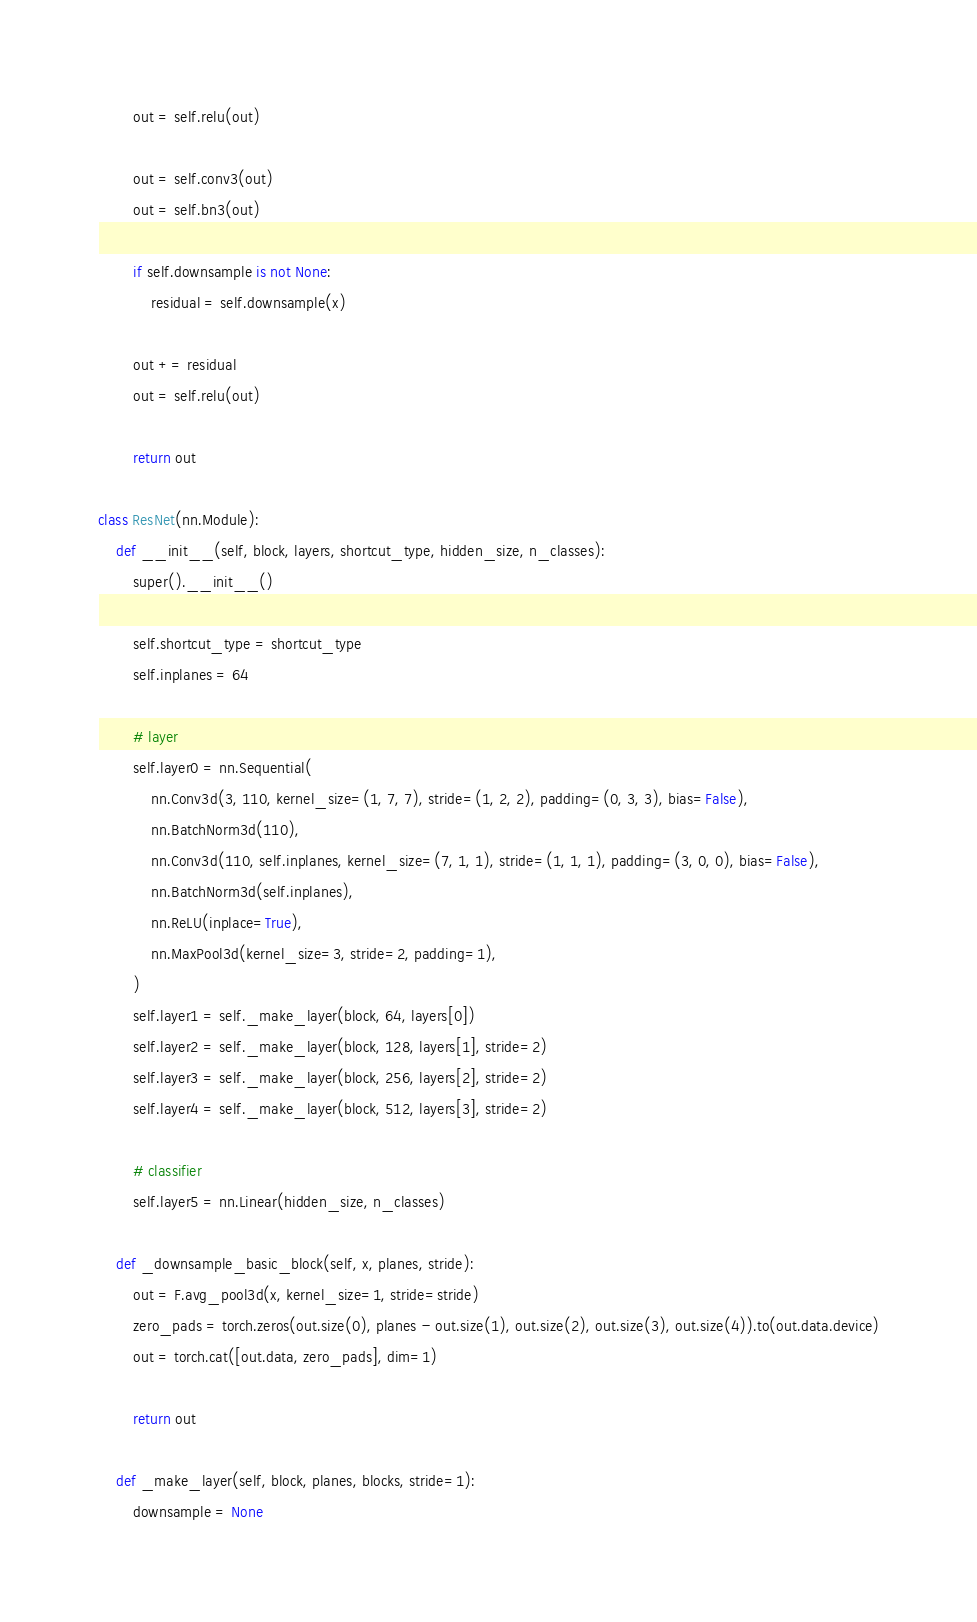<code> <loc_0><loc_0><loc_500><loc_500><_Python_>        out = self.relu(out)

        out = self.conv3(out)
        out = self.bn3(out)

        if self.downsample is not None:
            residual = self.downsample(x)

        out += residual
        out = self.relu(out)

        return out

class ResNet(nn.Module):
    def __init__(self, block, layers, shortcut_type, hidden_size, n_classes):
        super().__init__()

        self.shortcut_type = shortcut_type
        self.inplanes = 64

        # layer
        self.layer0 = nn.Sequential(
            nn.Conv3d(3, 110, kernel_size=(1, 7, 7), stride=(1, 2, 2), padding=(0, 3, 3), bias=False),
            nn.BatchNorm3d(110),
            nn.Conv3d(110, self.inplanes, kernel_size=(7, 1, 1), stride=(1, 1, 1), padding=(3, 0, 0), bias=False),
            nn.BatchNorm3d(self.inplanes),
            nn.ReLU(inplace=True),
            nn.MaxPool3d(kernel_size=3, stride=2, padding=1),
        )
        self.layer1 = self._make_layer(block, 64, layers[0])
        self.layer2 = self._make_layer(block, 128, layers[1], stride=2)
        self.layer3 = self._make_layer(block, 256, layers[2], stride=2)
        self.layer4 = self._make_layer(block, 512, layers[3], stride=2)

        # classifier
        self.layer5 = nn.Linear(hidden_size, n_classes)

    def _downsample_basic_block(self, x, planes, stride):
        out = F.avg_pool3d(x, kernel_size=1, stride=stride)
        zero_pads = torch.zeros(out.size(0), planes - out.size(1), out.size(2), out.size(3), out.size(4)).to(out.data.device)
        out = torch.cat([out.data, zero_pads], dim=1)

        return out

    def _make_layer(self, block, planes, blocks, stride=1):
        downsample = None</code> 